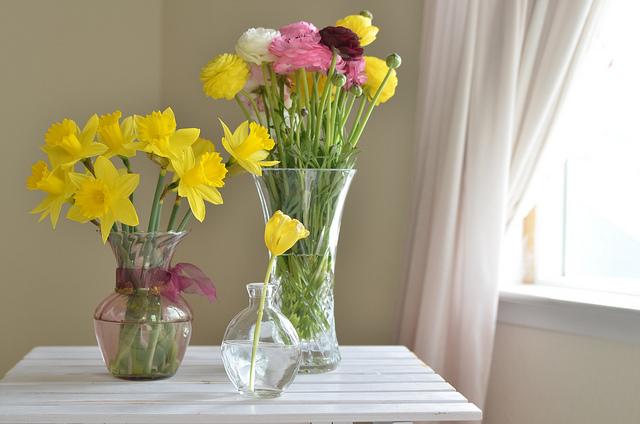How many vases are there?
Concise answer only. 3. Do all the daffodils share one vase?
Concise answer only. No. What color is the table?
Short answer required. White. How many big yellow flowers are there?
Concise answer only. 12. 